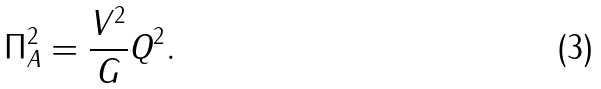Convert formula to latex. <formula><loc_0><loc_0><loc_500><loc_500>\Pi _ { A } ^ { 2 } = \frac { V ^ { 2 } } { G } Q ^ { 2 } .</formula> 